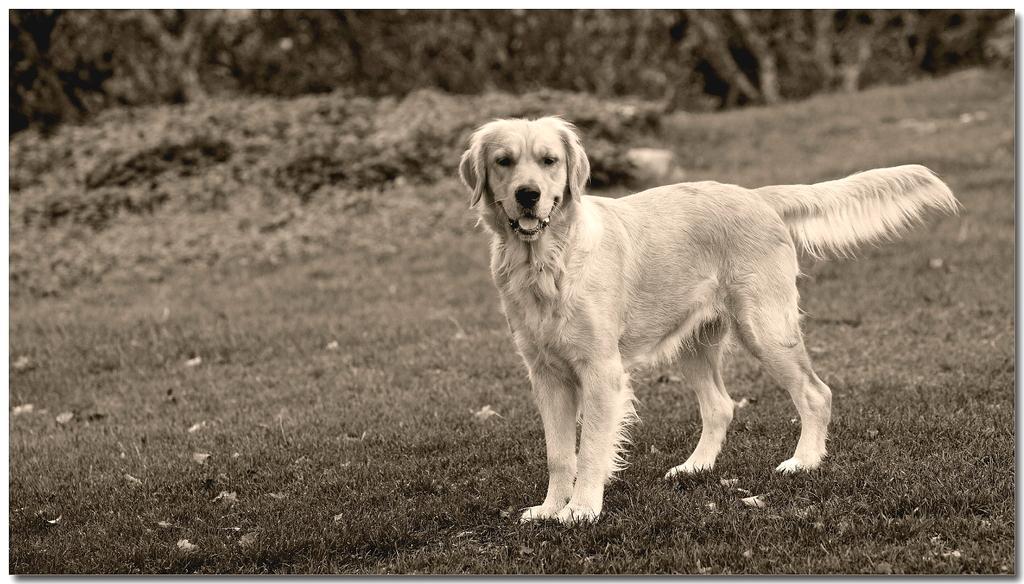Please provide a concise description of this image. In this image in the front there is a dog. In the background there are trees and plants and there are dry leaves on the ground. 